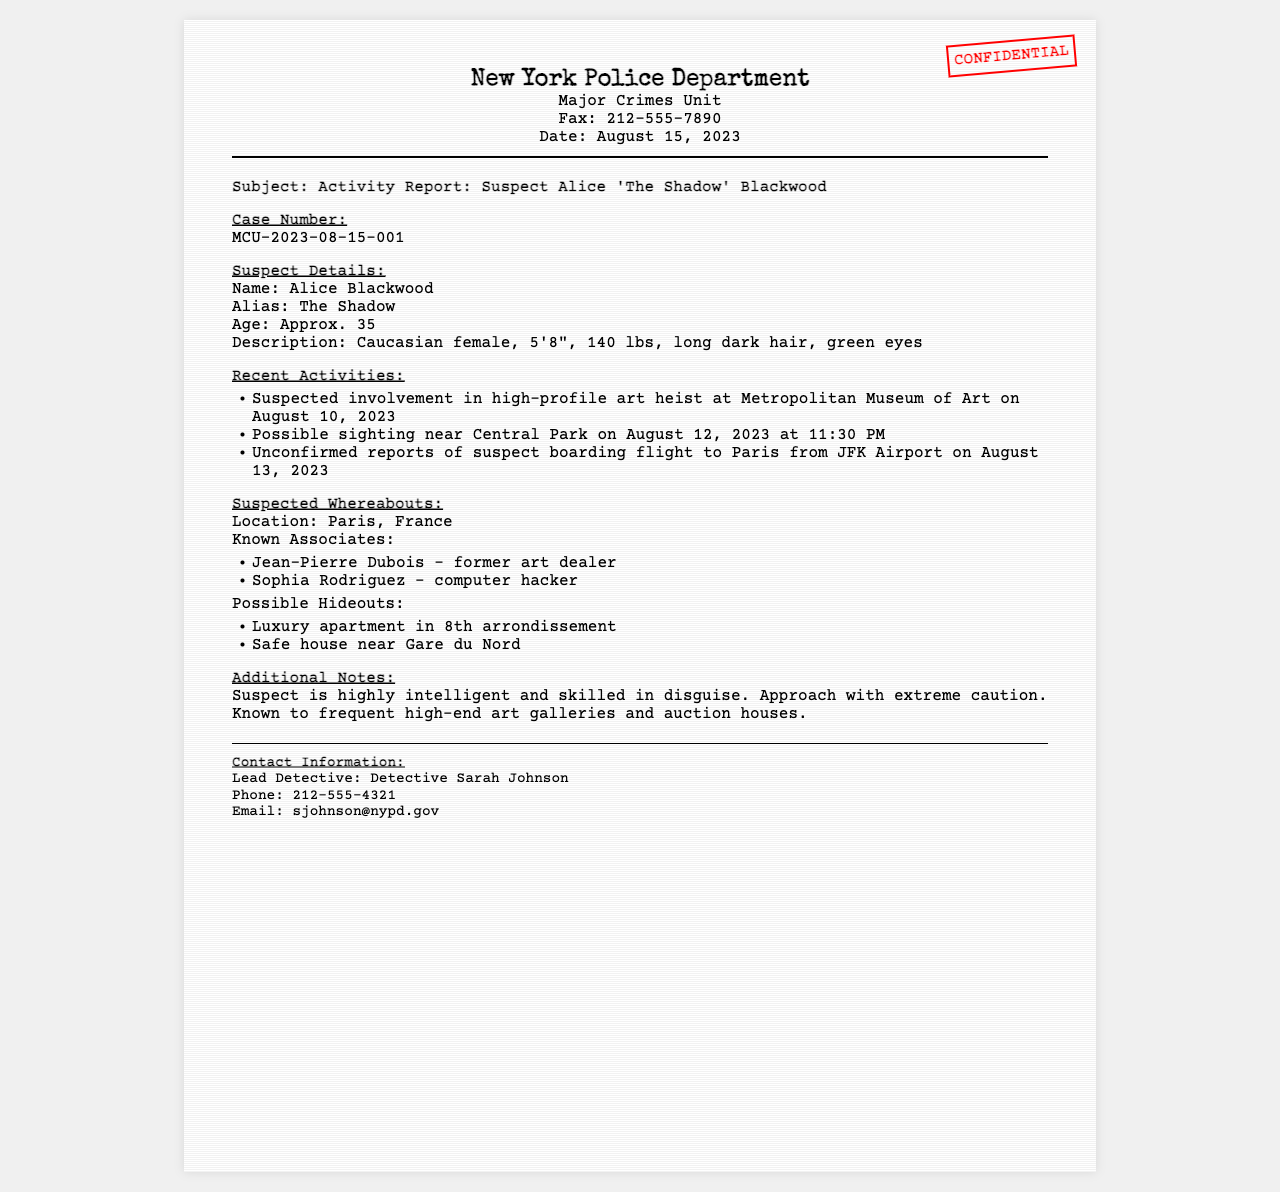What is the subject of the fax? The subject line details the report's focus on the suspect.
Answer: Activity Report: Suspect Alice 'The Shadow' Blackwood What is the date of the report? The date is mentioned in the header of the fax document.
Answer: August 15, 2023 What is the alias of the suspect? The alias is specifically provided in the suspect details section.
Answer: The Shadow Where was the suspect possibly sighted? The sighting location is noted in the recent activities section of the report.
Answer: Central Park Who is the lead detective? The lead detective's name is included in the contact information at the bottom of the fax.
Answer: Detective Sarah Johnson What was the suspected activity on August 10, 2023? The report lists this incident as part of the recent activities of the suspect.
Answer: Art heist How old is the suspect? The age is directly stated in the suspect details section.
Answer: Approx. 35 What are the known associates of the suspect? The report lists individuals associated with the suspect under suspected whereabouts.
Answer: Jean-Pierre Dubois, Sophia Rodriguez What is a possible hideout location mentioned? The report outlines potential hideouts for the suspect.
Answer: Luxury apartment in 8th arrondissement Which airport was the suspect possibly boarding a flight from? The document specifies the airport related to the suspect's recent activities.
Answer: JFK Airport 